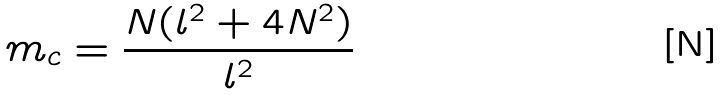Convert formula to latex. <formula><loc_0><loc_0><loc_500><loc_500>m _ { c } = \frac { N ( l ^ { 2 } + 4 N ^ { 2 } ) } { l ^ { 2 } }</formula> 